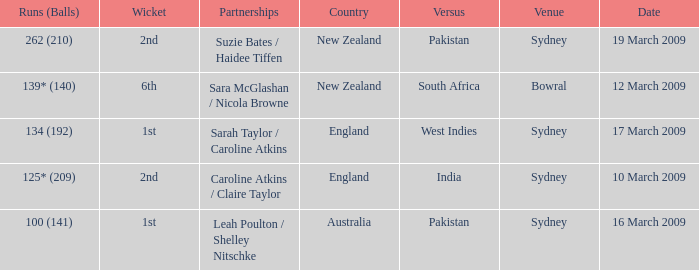How many times was the opponent country India?  1.0. 